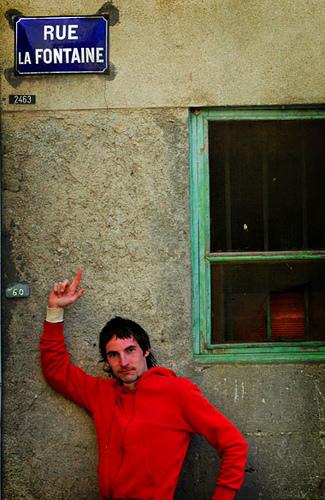Is this a man or a woman?
Quick response, please. Man. What color is the shirt?
Be succinct. Red. What color is the sign on the back wall?
Keep it brief. Blue. What color is his sweater?
Write a very short answer. Red. What language is the sign in?
Answer briefly. French. Is the man drunk?
Give a very brief answer. Yes. What is the number above the door?
Answer briefly. 2463. 